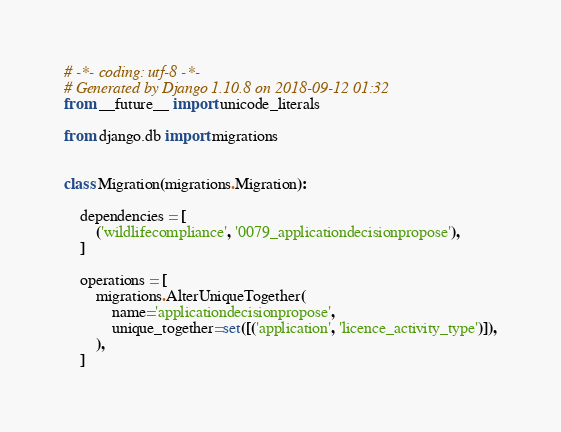Convert code to text. <code><loc_0><loc_0><loc_500><loc_500><_Python_># -*- coding: utf-8 -*-
# Generated by Django 1.10.8 on 2018-09-12 01:32
from __future__ import unicode_literals

from django.db import migrations


class Migration(migrations.Migration):

    dependencies = [
        ('wildlifecompliance', '0079_applicationdecisionpropose'),
    ]

    operations = [
        migrations.AlterUniqueTogether(
            name='applicationdecisionpropose',
            unique_together=set([('application', 'licence_activity_type')]),
        ),
    ]
</code> 